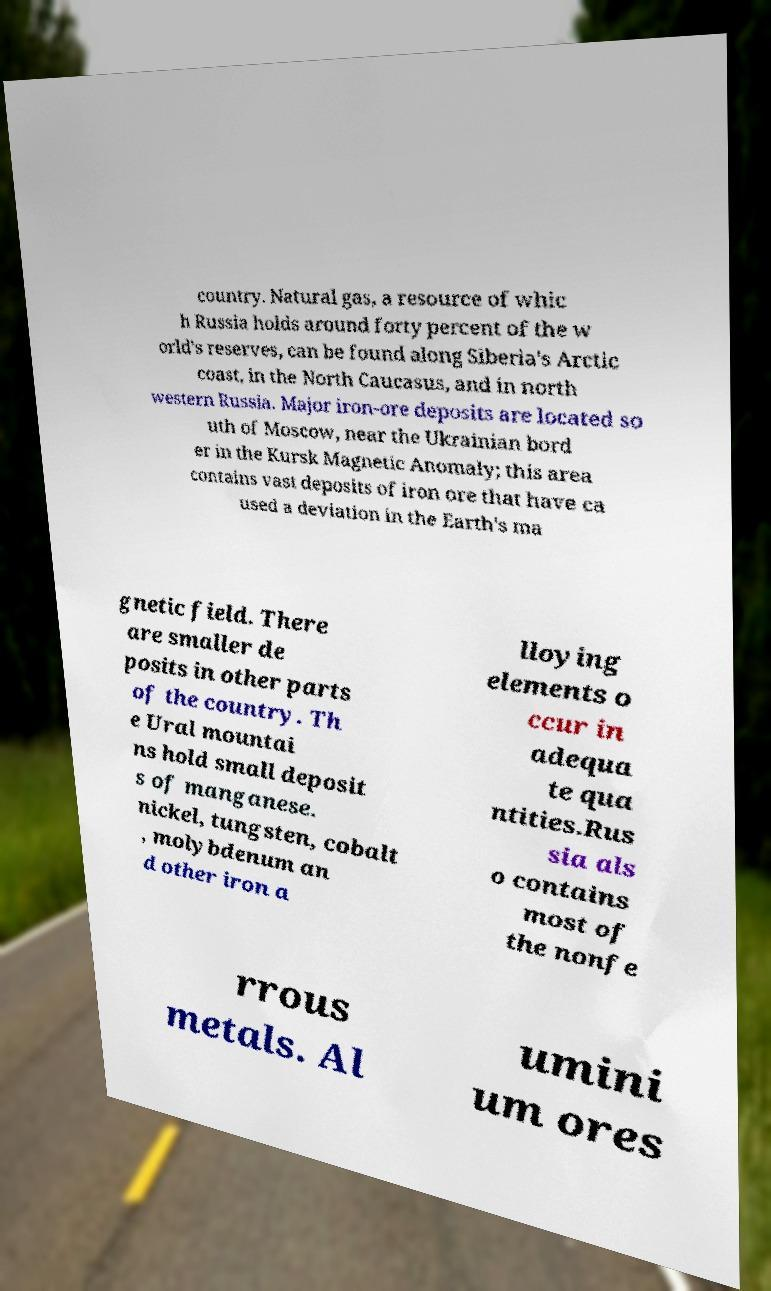Can you read and provide the text displayed in the image?This photo seems to have some interesting text. Can you extract and type it out for me? country. Natural gas, a resource of whic h Russia holds around forty percent of the w orld's reserves, can be found along Siberia's Arctic coast, in the North Caucasus, and in north western Russia. Major iron-ore deposits are located so uth of Moscow, near the Ukrainian bord er in the Kursk Magnetic Anomaly; this area contains vast deposits of iron ore that have ca used a deviation in the Earth's ma gnetic field. There are smaller de posits in other parts of the country. Th e Ural mountai ns hold small deposit s of manganese. nickel, tungsten, cobalt , molybdenum an d other iron a lloying elements o ccur in adequa te qua ntities.Rus sia als o contains most of the nonfe rrous metals. Al umini um ores 